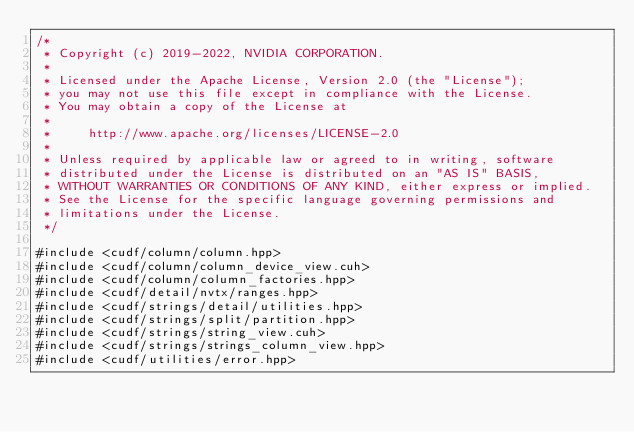<code> <loc_0><loc_0><loc_500><loc_500><_Cuda_>/*
 * Copyright (c) 2019-2022, NVIDIA CORPORATION.
 *
 * Licensed under the Apache License, Version 2.0 (the "License");
 * you may not use this file except in compliance with the License.
 * You may obtain a copy of the License at
 *
 *     http://www.apache.org/licenses/LICENSE-2.0
 *
 * Unless required by applicable law or agreed to in writing, software
 * distributed under the License is distributed on an "AS IS" BASIS,
 * WITHOUT WARRANTIES OR CONDITIONS OF ANY KIND, either express or implied.
 * See the License for the specific language governing permissions and
 * limitations under the License.
 */

#include <cudf/column/column.hpp>
#include <cudf/column/column_device_view.cuh>
#include <cudf/column/column_factories.hpp>
#include <cudf/detail/nvtx/ranges.hpp>
#include <cudf/strings/detail/utilities.hpp>
#include <cudf/strings/split/partition.hpp>
#include <cudf/strings/string_view.cuh>
#include <cudf/strings/strings_column_view.hpp>
#include <cudf/utilities/error.hpp>
</code> 